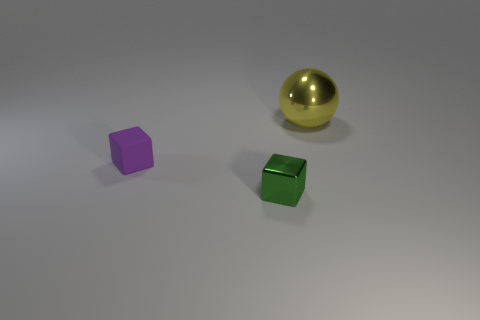Are there any other things that are the same size as the yellow object?
Your response must be concise. No. Is there anything else of the same color as the large object?
Provide a succinct answer. No. The ball is what color?
Keep it short and to the point. Yellow. Is there a small purple thing?
Keep it short and to the point. Yes. There is a green object; are there any blocks to the left of it?
Offer a terse response. Yes. There is another tiny object that is the same shape as the purple thing; what material is it?
Ensure brevity in your answer.  Metal. Is there anything else that has the same material as the purple cube?
Give a very brief answer. No. How many other things are there of the same shape as the green thing?
Provide a short and direct response. 1. There is a tiny block on the left side of the green metallic object to the right of the rubber block; what number of small objects are right of it?
Ensure brevity in your answer.  1. How many tiny green objects have the same shape as the big yellow metal thing?
Offer a terse response. 0. 